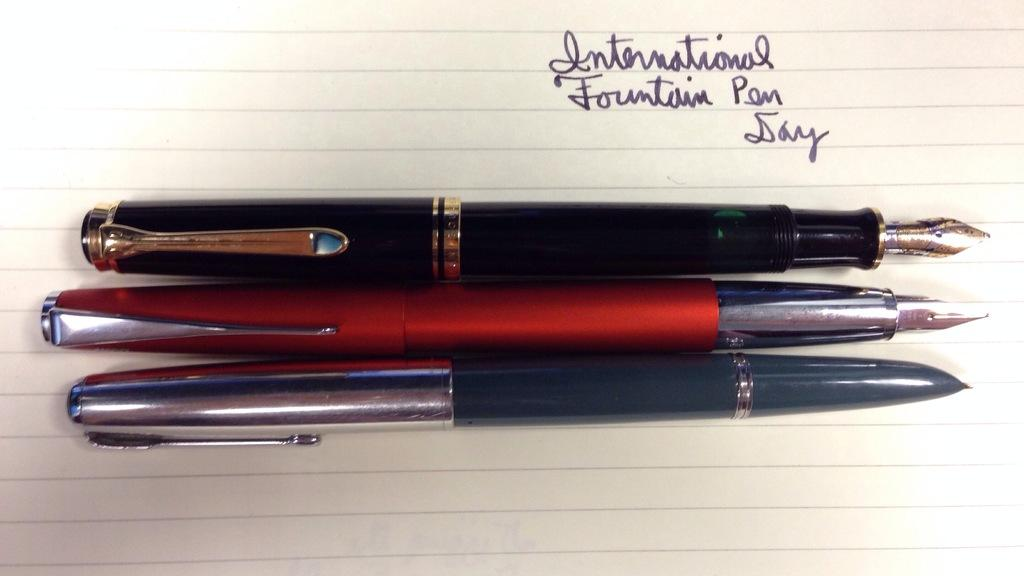How many pens are visible in the image? There are three pens in the image. What else is present in the image besides the pens? There is a paper with text in the image. How many lizards are crawling on the window in the image? There are no lizards or windows present in the image; it only features three pens and a paper with text. 